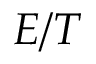Convert formula to latex. <formula><loc_0><loc_0><loc_500><loc_500>E / T</formula> 